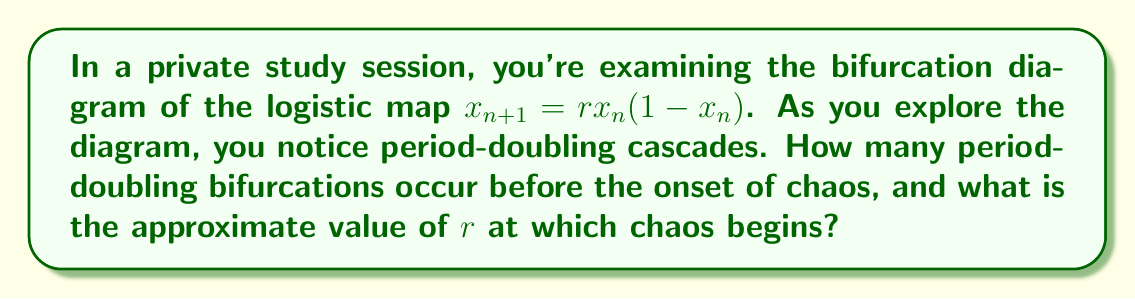Help me with this question. Let's approach this step-by-step:

1. The logistic map is given by the equation $x_{n+1} = rx_n(1-x_n)$, where $r$ is the bifurcation parameter.

2. As we increase $r$ from 0 to 4, we observe the following behavior in the bifurcation diagram:

   a) For $0 < r < 1$, the population dies out.
   b) At $r = 1$, the first bifurcation occurs.
   c) For $1 < r < 3$, there's a stable fixed point.
   d) At $r = 3$, the second bifurcation occurs, leading to a period-2 cycle.
   e) As $r$ increases further, we see period-doubling bifurcations:
      - Period-2 splits into period-4
      - Period-4 splits into period-8
      - Period-8 splits into period-16
      - And so on...

3. This sequence of period-doubling bifurcations continues, with each new bifurcation occurring at a smaller interval of $r$ than the previous one.

4. The number of visible period-doubling bifurcations before chaos is typically around 5-6 in most diagrams, though theoretically, an infinite number of doublings occur in a finite interval.

5. The onset of chaos occurs at the accumulation point of these period-doubling bifurcations. This point is known as the Feigenbaum point.

6. The approximate value of $r$ at the onset of chaos is $r \approx 3.57$, often referred to as the Feigenbaum constant.

Therefore, we typically observe about 5-6 visible period-doubling bifurcations before the onset of chaos, which occurs at approximately $r = 3.57$.
Answer: 5-6 visible bifurcations; chaos at $r \approx 3.57$ 